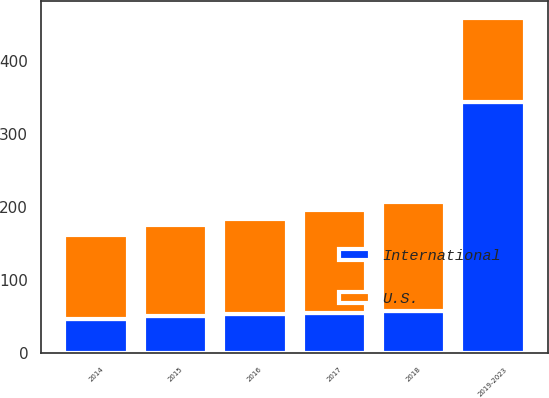<chart> <loc_0><loc_0><loc_500><loc_500><stacked_bar_chart><ecel><fcel>2014<fcel>2015<fcel>2016<fcel>2017<fcel>2018<fcel>2019-2023<nl><fcel>U.S.<fcel>115.6<fcel>124.7<fcel>130.3<fcel>141.3<fcel>148.8<fcel>115.6<nl><fcel>International<fcel>46.4<fcel>51.3<fcel>53.3<fcel>54.8<fcel>57.7<fcel>344.1<nl></chart> 